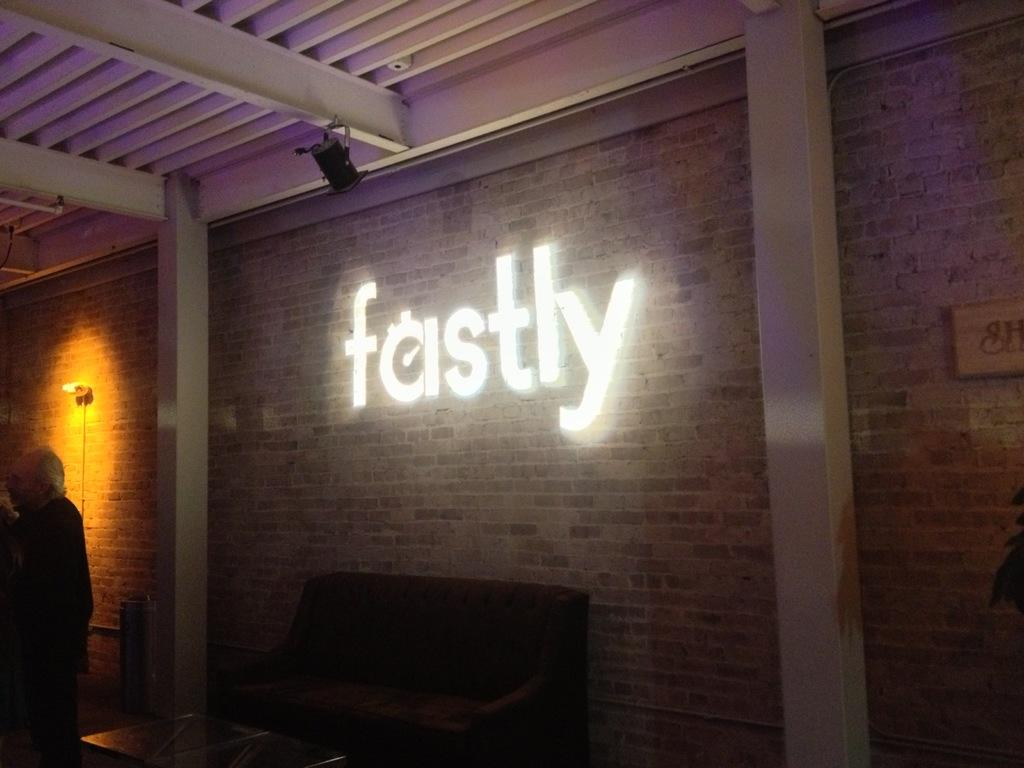What type of setting is depicted in the image? The image is of an indoor setting. What is located in the center of the image? There is a couch and a table in the center of the image. Can you describe the man's position in the image? There is a man standing on the left side of the image. What can be seen in the background of the image? There is a brick wall and a text with lights in the background of the image. How does the harmony between the man and the couch change every minute in the image? The image does not depict any changes in harmony between the man and the couch, nor does it show any time-based progression. 